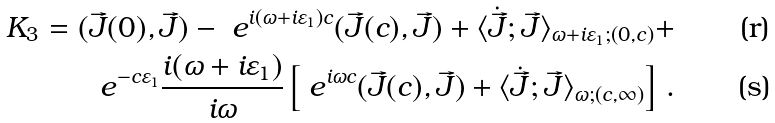<formula> <loc_0><loc_0><loc_500><loc_500>K _ { 3 } = ( \vec { J } ( 0 ) , \vec { J } ) - \ e ^ { i ( \omega + i \varepsilon _ { 1 } ) c } ( \vec { J } ( c ) , \vec { J } ) + \langle \dot { \vec { J } } ; \vec { J } \rangle _ { \omega + i \varepsilon _ { 1 } ; ( 0 , c ) } + \\ \ e ^ { - c \varepsilon _ { 1 } } \frac { i ( \omega + i \varepsilon _ { 1 } ) } { i \omega } \left [ \ e ^ { i \omega c } ( \vec { J } ( c ) , \vec { J } ) + \langle \dot { \vec { J } } ; \vec { J } \rangle _ { \omega ; ( c , \infty ) } \right ] \, .</formula> 